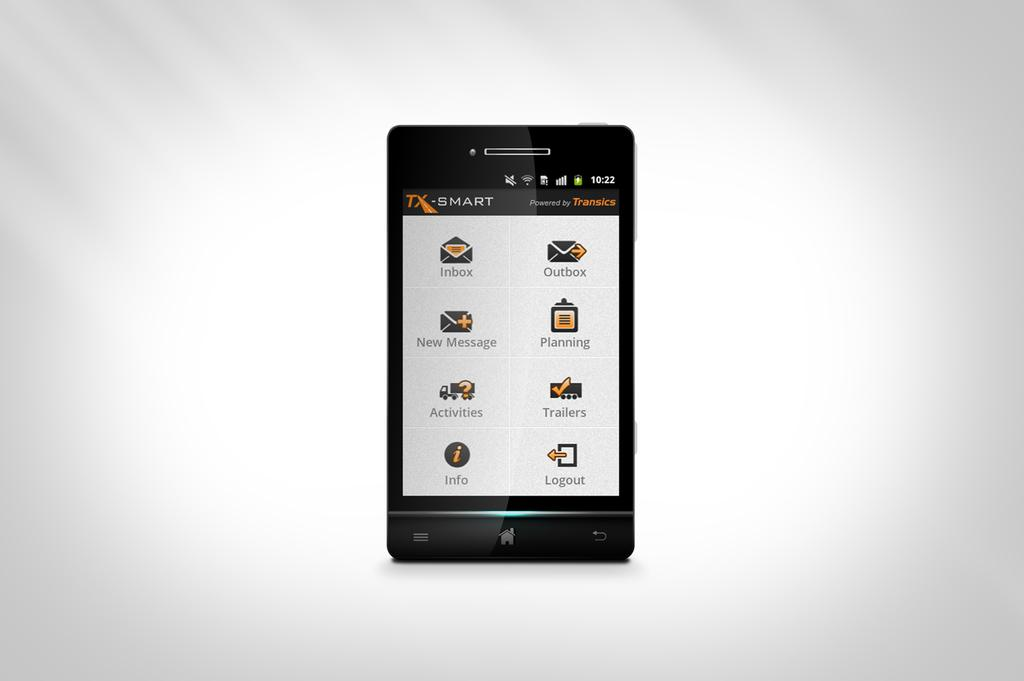<image>
Relay a brief, clear account of the picture shown. The little phone standing up by itself is powered by Transics. 